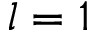<formula> <loc_0><loc_0><loc_500><loc_500>l = 1</formula> 